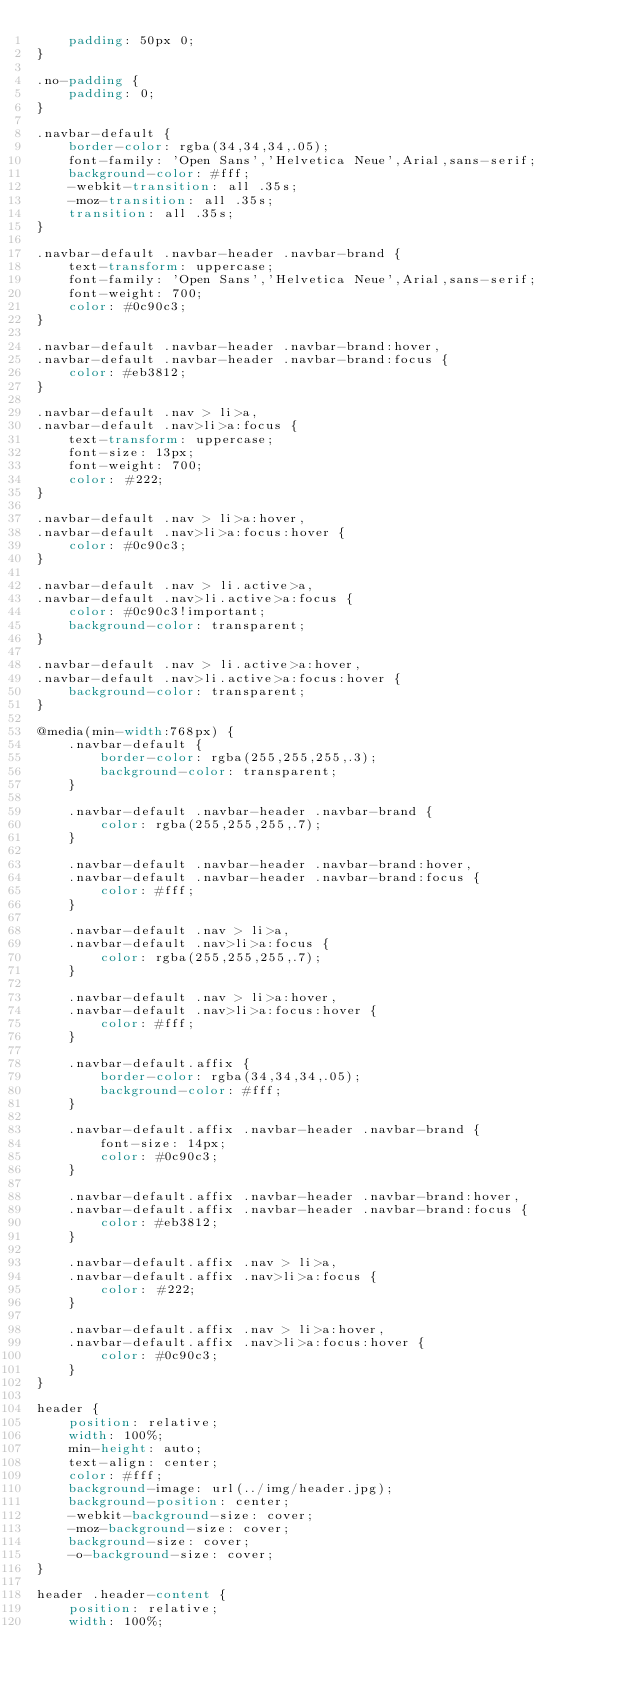Convert code to text. <code><loc_0><loc_0><loc_500><loc_500><_CSS_>    padding: 50px 0;
}

.no-padding {
    padding: 0;
}

.navbar-default {
    border-color: rgba(34,34,34,.05);
    font-family: 'Open Sans','Helvetica Neue',Arial,sans-serif;
    background-color: #fff;
    -webkit-transition: all .35s;
    -moz-transition: all .35s;
    transition: all .35s;
}

.navbar-default .navbar-header .navbar-brand {
    text-transform: uppercase;
    font-family: 'Open Sans','Helvetica Neue',Arial,sans-serif;
    font-weight: 700;
    color: #0c90c3;
}

.navbar-default .navbar-header .navbar-brand:hover,
.navbar-default .navbar-header .navbar-brand:focus {
    color: #eb3812;
}

.navbar-default .nav > li>a,
.navbar-default .nav>li>a:focus {
    text-transform: uppercase;
    font-size: 13px;
    font-weight: 700;
    color: #222;
}

.navbar-default .nav > li>a:hover,
.navbar-default .nav>li>a:focus:hover {
    color: #0c90c3;
}

.navbar-default .nav > li.active>a,
.navbar-default .nav>li.active>a:focus {
    color: #0c90c3!important;
    background-color: transparent;
}

.navbar-default .nav > li.active>a:hover,
.navbar-default .nav>li.active>a:focus:hover {
    background-color: transparent;
}

@media(min-width:768px) {
    .navbar-default {
        border-color: rgba(255,255,255,.3);
        background-color: transparent;
    }

    .navbar-default .navbar-header .navbar-brand {
        color: rgba(255,255,255,.7);
    }

    .navbar-default .navbar-header .navbar-brand:hover,
    .navbar-default .navbar-header .navbar-brand:focus {
        color: #fff;
    }

    .navbar-default .nav > li>a,
    .navbar-default .nav>li>a:focus {
        color: rgba(255,255,255,.7);
    }

    .navbar-default .nav > li>a:hover,
    .navbar-default .nav>li>a:focus:hover {
        color: #fff;
    }

    .navbar-default.affix {
        border-color: rgba(34,34,34,.05);
        background-color: #fff;
    }

    .navbar-default.affix .navbar-header .navbar-brand {
        font-size: 14px;
        color: #0c90c3;
    }

    .navbar-default.affix .navbar-header .navbar-brand:hover,
    .navbar-default.affix .navbar-header .navbar-brand:focus {
        color: #eb3812;
    }

    .navbar-default.affix .nav > li>a,
    .navbar-default.affix .nav>li>a:focus {
        color: #222;
    }

    .navbar-default.affix .nav > li>a:hover,
    .navbar-default.affix .nav>li>a:focus:hover {
        color: #0c90c3;
    }
}

header {
    position: relative;
    width: 100%;
    min-height: auto;
    text-align: center;
    color: #fff;
    background-image: url(../img/header.jpg);
    background-position: center;
    -webkit-background-size: cover;
    -moz-background-size: cover;
    background-size: cover;
    -o-background-size: cover;
}

header .header-content {
    position: relative;
    width: 100%;</code> 